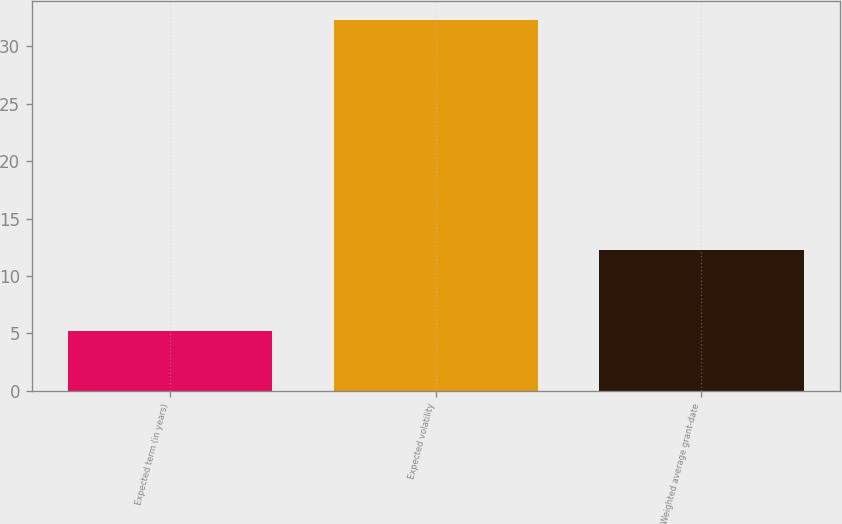<chart> <loc_0><loc_0><loc_500><loc_500><bar_chart><fcel>Expected term (in years)<fcel>Expected volatility<fcel>Weighted average grant-date<nl><fcel>5.2<fcel>32.3<fcel>12.28<nl></chart> 